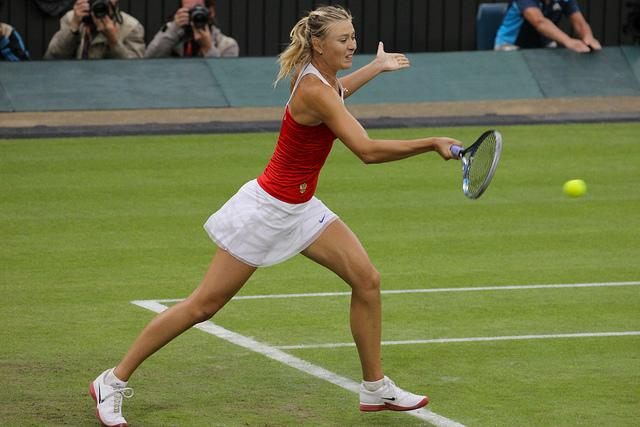What type of shot is the woman hitting? forehand 